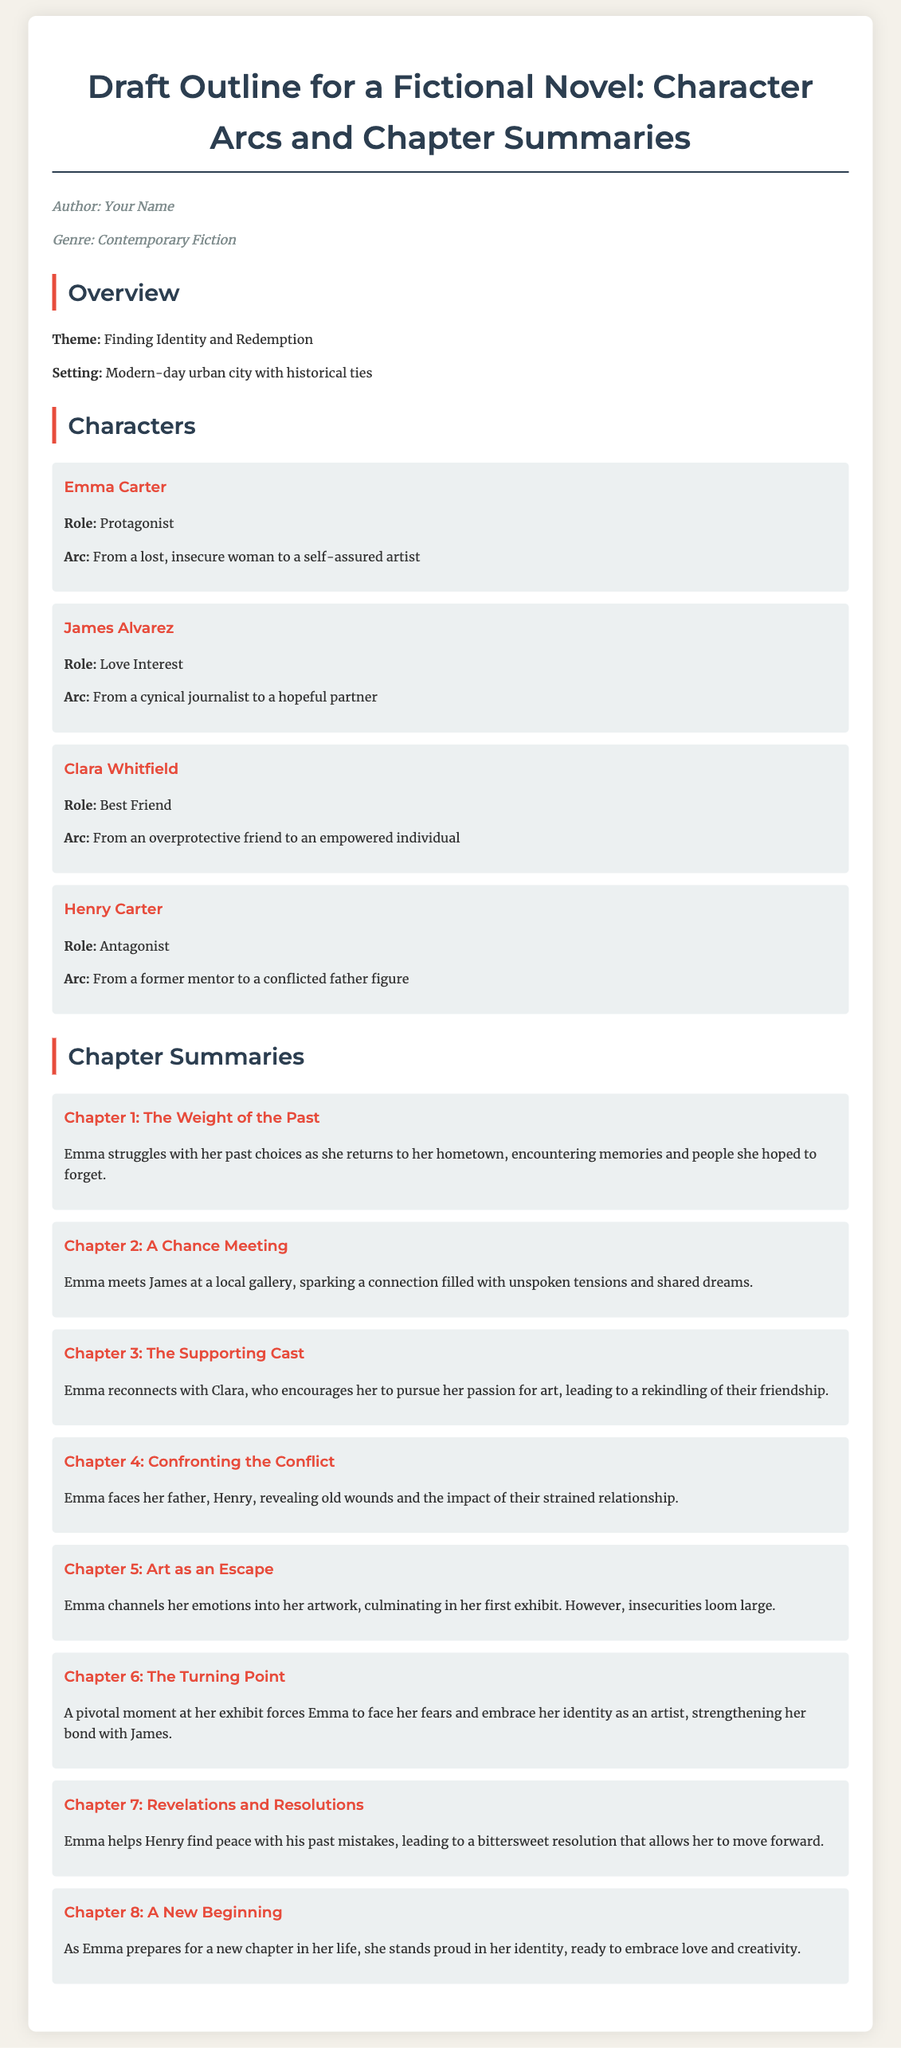What is the genre of the novel? The genre is listed under the author information section in the document.
Answer: Contemporary Fiction Who is the protagonist of the story? The protagonist's role and name are specified in the characters section of the document.
Answer: Emma Carter What is Emma Carter's character arc? The document provides a summary of each character's arc under their respective descriptions.
Answer: From a lost, insecure woman to a self-assured artist How many chapters are summarized in the document? The number of chapters can be counted in the chapters section of the document.
Answer: Eight What chapter deals with Emma's first exhibit? The summary for each chapter specifies its focus, allowing for identification of the right chapter.
Answer: Chapter 5 What is the title of Chapter 1? The titles of each chapter are listed in the chapter summaries, which includes their headings.
Answer: The Weight of the Past Which character supports Emma in pursuing her passion? The characters section describes the roles and relationships between characters.
Answer: Clara Whitfield What major theme is explored in the novel? The theme is clearly stated in the overview section of the document.
Answer: Finding Identity and Redemption 